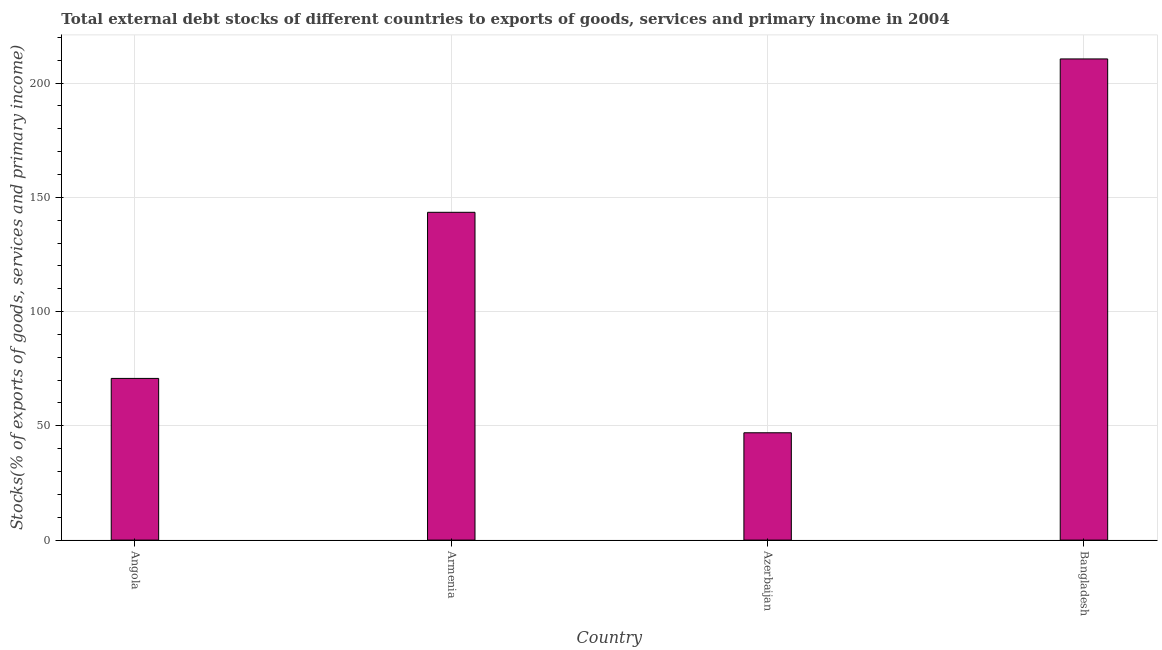Does the graph contain any zero values?
Offer a terse response. No. Does the graph contain grids?
Give a very brief answer. Yes. What is the title of the graph?
Offer a very short reply. Total external debt stocks of different countries to exports of goods, services and primary income in 2004. What is the label or title of the X-axis?
Offer a terse response. Country. What is the label or title of the Y-axis?
Offer a very short reply. Stocks(% of exports of goods, services and primary income). What is the external debt stocks in Angola?
Provide a succinct answer. 70.76. Across all countries, what is the maximum external debt stocks?
Provide a short and direct response. 210.57. Across all countries, what is the minimum external debt stocks?
Provide a short and direct response. 46.97. In which country was the external debt stocks maximum?
Provide a succinct answer. Bangladesh. In which country was the external debt stocks minimum?
Give a very brief answer. Azerbaijan. What is the sum of the external debt stocks?
Your response must be concise. 471.74. What is the difference between the external debt stocks in Angola and Azerbaijan?
Your answer should be very brief. 23.79. What is the average external debt stocks per country?
Offer a very short reply. 117.94. What is the median external debt stocks?
Your response must be concise. 107.1. In how many countries, is the external debt stocks greater than 130 %?
Your answer should be compact. 2. What is the ratio of the external debt stocks in Azerbaijan to that in Bangladesh?
Provide a short and direct response. 0.22. Is the difference between the external debt stocks in Angola and Azerbaijan greater than the difference between any two countries?
Provide a succinct answer. No. What is the difference between the highest and the second highest external debt stocks?
Offer a very short reply. 67.12. What is the difference between the highest and the lowest external debt stocks?
Your answer should be very brief. 163.6. Are all the bars in the graph horizontal?
Your answer should be very brief. No. How many countries are there in the graph?
Provide a succinct answer. 4. Are the values on the major ticks of Y-axis written in scientific E-notation?
Give a very brief answer. No. What is the Stocks(% of exports of goods, services and primary income) of Angola?
Your answer should be very brief. 70.76. What is the Stocks(% of exports of goods, services and primary income) in Armenia?
Ensure brevity in your answer.  143.45. What is the Stocks(% of exports of goods, services and primary income) in Azerbaijan?
Your response must be concise. 46.97. What is the Stocks(% of exports of goods, services and primary income) in Bangladesh?
Offer a very short reply. 210.57. What is the difference between the Stocks(% of exports of goods, services and primary income) in Angola and Armenia?
Your answer should be compact. -72.69. What is the difference between the Stocks(% of exports of goods, services and primary income) in Angola and Azerbaijan?
Ensure brevity in your answer.  23.79. What is the difference between the Stocks(% of exports of goods, services and primary income) in Angola and Bangladesh?
Offer a very short reply. -139.81. What is the difference between the Stocks(% of exports of goods, services and primary income) in Armenia and Azerbaijan?
Make the answer very short. 96.48. What is the difference between the Stocks(% of exports of goods, services and primary income) in Armenia and Bangladesh?
Your answer should be very brief. -67.12. What is the difference between the Stocks(% of exports of goods, services and primary income) in Azerbaijan and Bangladesh?
Offer a very short reply. -163.6. What is the ratio of the Stocks(% of exports of goods, services and primary income) in Angola to that in Armenia?
Ensure brevity in your answer.  0.49. What is the ratio of the Stocks(% of exports of goods, services and primary income) in Angola to that in Azerbaijan?
Ensure brevity in your answer.  1.51. What is the ratio of the Stocks(% of exports of goods, services and primary income) in Angola to that in Bangladesh?
Ensure brevity in your answer.  0.34. What is the ratio of the Stocks(% of exports of goods, services and primary income) in Armenia to that in Azerbaijan?
Offer a terse response. 3.05. What is the ratio of the Stocks(% of exports of goods, services and primary income) in Armenia to that in Bangladesh?
Make the answer very short. 0.68. What is the ratio of the Stocks(% of exports of goods, services and primary income) in Azerbaijan to that in Bangladesh?
Provide a short and direct response. 0.22. 